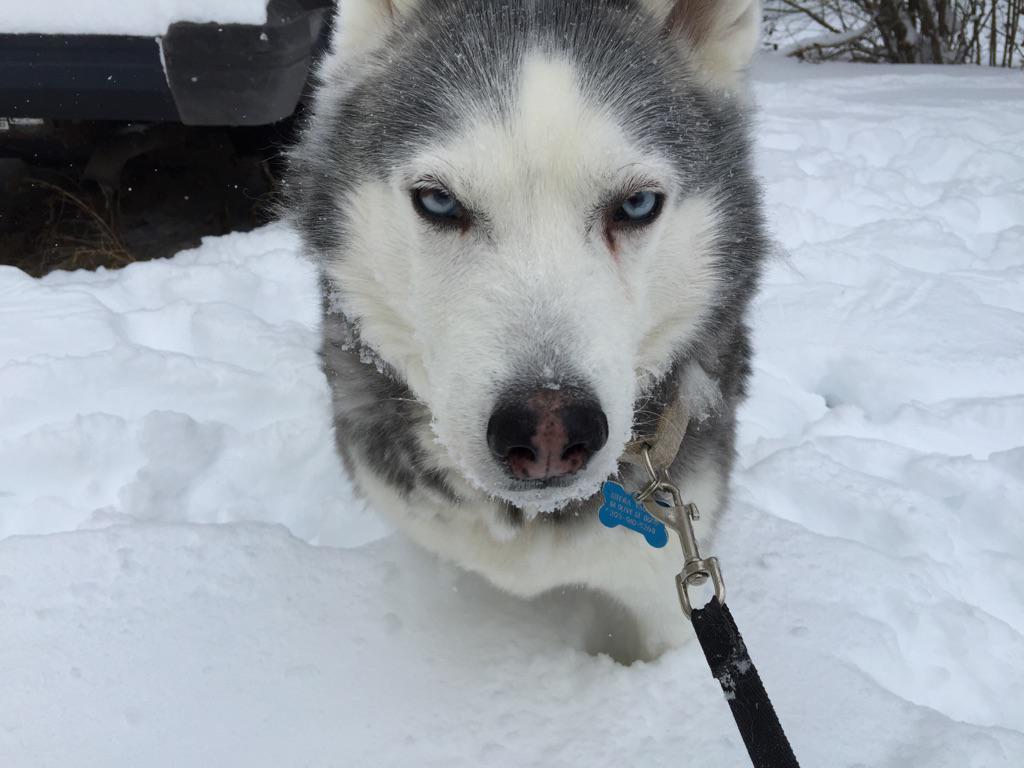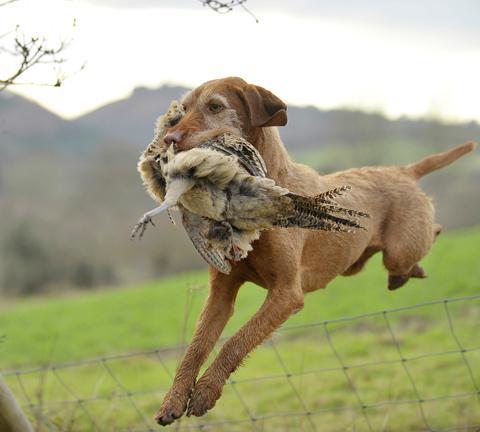The first image is the image on the left, the second image is the image on the right. Evaluate the accuracy of this statement regarding the images: "There are three animals.". Is it true? Answer yes or no. Yes. The first image is the image on the left, the second image is the image on the right. Examine the images to the left and right. Is the description "In at least one image there is a red hound with a collar sitting in the grass." accurate? Answer yes or no. No. 